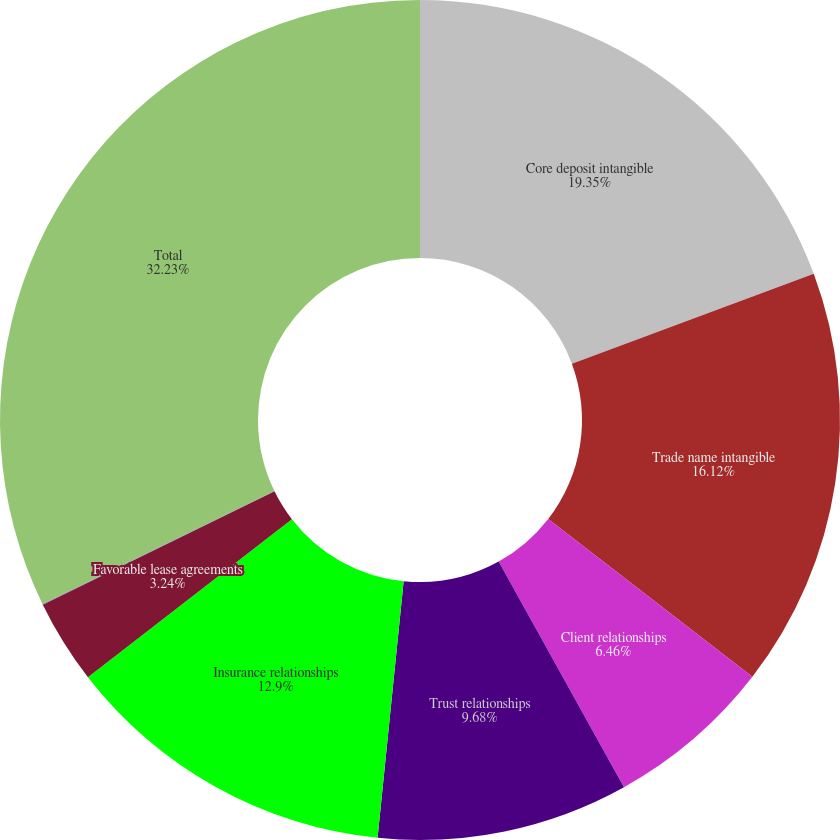<chart> <loc_0><loc_0><loc_500><loc_500><pie_chart><fcel>Core deposit intangible<fcel>Trade name intangible<fcel>Client relationships<fcel>Trust relationships<fcel>Insurance relationships<fcel>Favorable lease agreements<fcel>Non-compete agreements<fcel>Total<nl><fcel>19.34%<fcel>16.12%<fcel>6.46%<fcel>9.68%<fcel>12.9%<fcel>3.24%<fcel>0.02%<fcel>32.22%<nl></chart> 